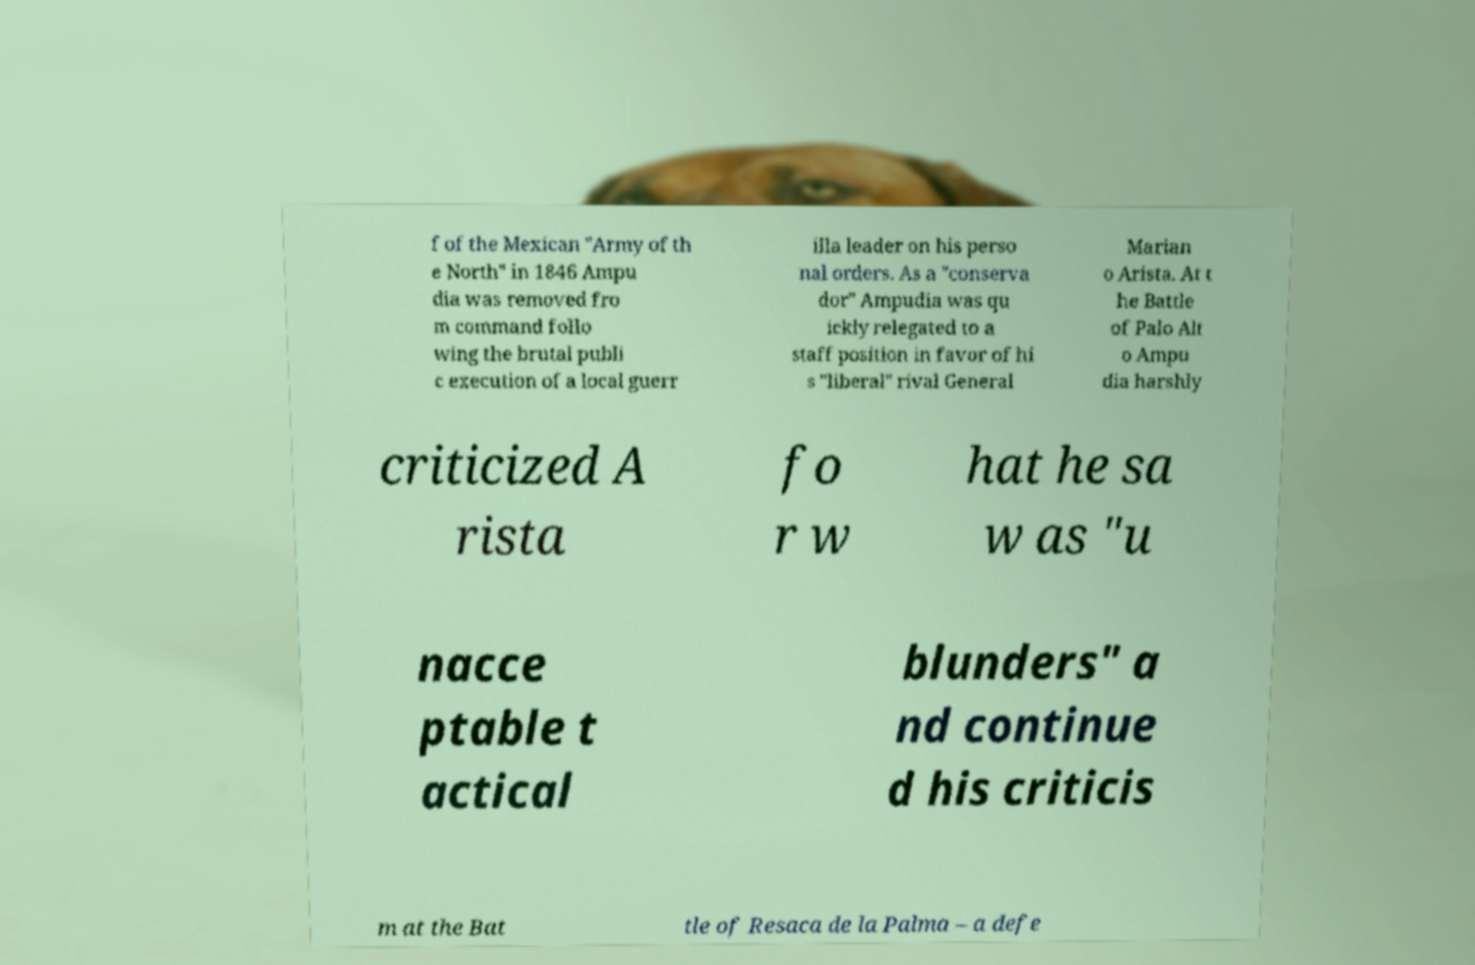Could you extract and type out the text from this image? f of the Mexican "Army of th e North" in 1846 Ampu dia was removed fro m command follo wing the brutal publi c execution of a local guerr illa leader on his perso nal orders. As a "conserva dor" Ampudia was qu ickly relegated to a staff position in favor of hi s "liberal" rival General Marian o Arista. At t he Battle of Palo Alt o Ampu dia harshly criticized A rista fo r w hat he sa w as "u nacce ptable t actical blunders" a nd continue d his criticis m at the Bat tle of Resaca de la Palma – a defe 